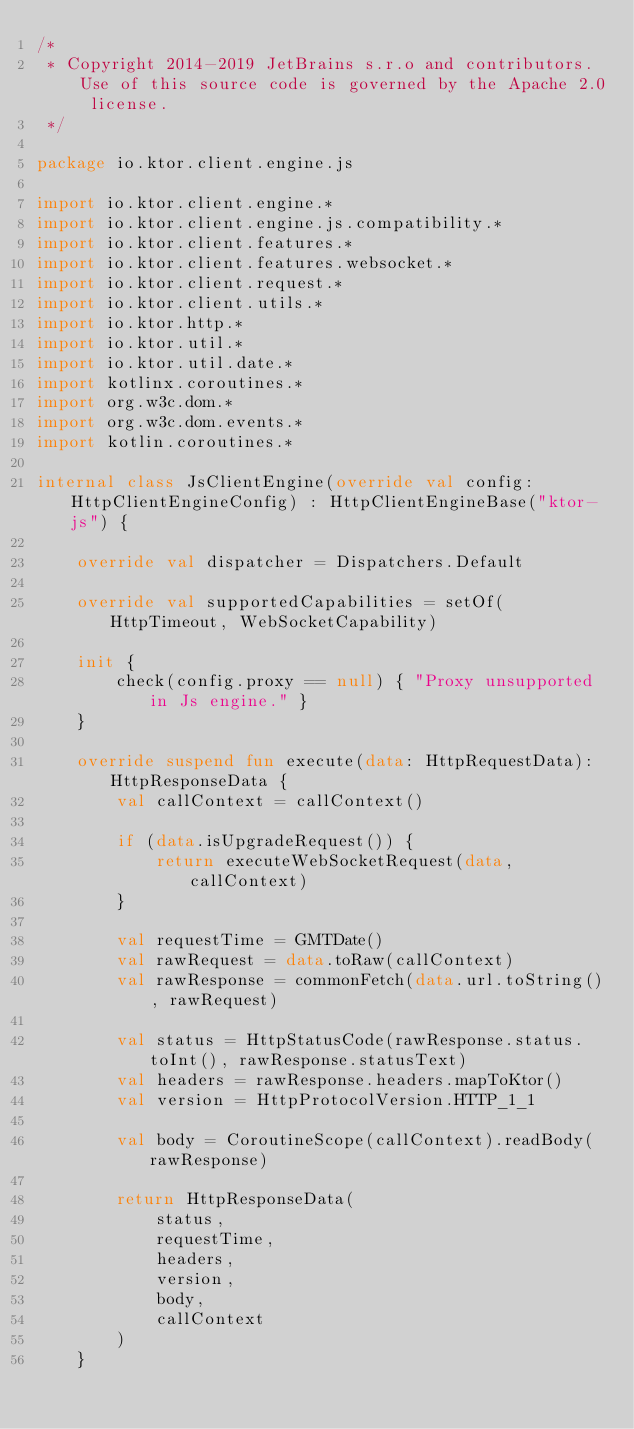Convert code to text. <code><loc_0><loc_0><loc_500><loc_500><_Kotlin_>/*
 * Copyright 2014-2019 JetBrains s.r.o and contributors. Use of this source code is governed by the Apache 2.0 license.
 */

package io.ktor.client.engine.js

import io.ktor.client.engine.*
import io.ktor.client.engine.js.compatibility.*
import io.ktor.client.features.*
import io.ktor.client.features.websocket.*
import io.ktor.client.request.*
import io.ktor.client.utils.*
import io.ktor.http.*
import io.ktor.util.*
import io.ktor.util.date.*
import kotlinx.coroutines.*
import org.w3c.dom.*
import org.w3c.dom.events.*
import kotlin.coroutines.*

internal class JsClientEngine(override val config: HttpClientEngineConfig) : HttpClientEngineBase("ktor-js") {

    override val dispatcher = Dispatchers.Default

    override val supportedCapabilities = setOf(HttpTimeout, WebSocketCapability)

    init {
        check(config.proxy == null) { "Proxy unsupported in Js engine." }
    }

    override suspend fun execute(data: HttpRequestData): HttpResponseData {
        val callContext = callContext()

        if (data.isUpgradeRequest()) {
            return executeWebSocketRequest(data, callContext)
        }

        val requestTime = GMTDate()
        val rawRequest = data.toRaw(callContext)
        val rawResponse = commonFetch(data.url.toString(), rawRequest)

        val status = HttpStatusCode(rawResponse.status.toInt(), rawResponse.statusText)
        val headers = rawResponse.headers.mapToKtor()
        val version = HttpProtocolVersion.HTTP_1_1

        val body = CoroutineScope(callContext).readBody(rawResponse)

        return HttpResponseData(
            status,
            requestTime,
            headers,
            version,
            body,
            callContext
        )
    }
</code> 